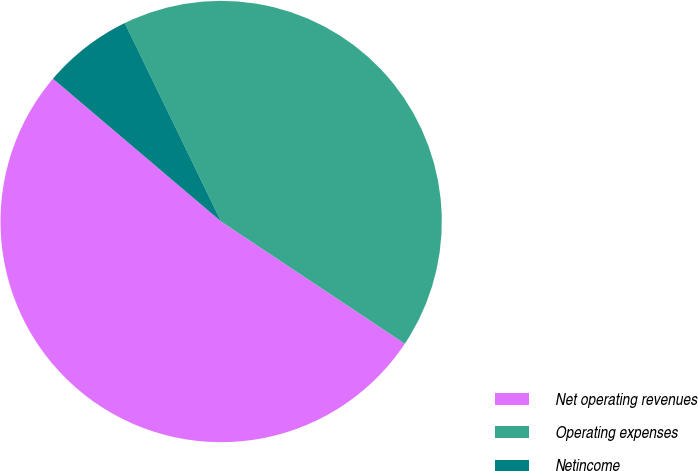<chart> <loc_0><loc_0><loc_500><loc_500><pie_chart><fcel>Net operating revenues<fcel>Operating expenses<fcel>Netincome<nl><fcel>51.86%<fcel>41.54%<fcel>6.6%<nl></chart> 